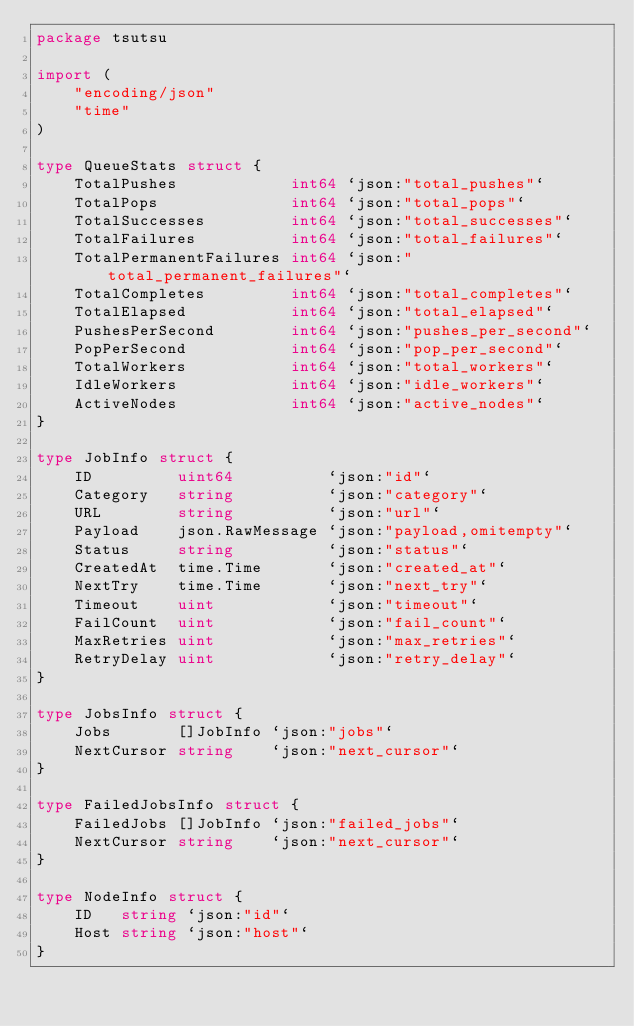Convert code to text. <code><loc_0><loc_0><loc_500><loc_500><_Go_>package tsutsu

import (
	"encoding/json"
	"time"
)

type QueueStats struct {
	TotalPushes            int64 `json:"total_pushes"`
	TotalPops              int64 `json:"total_pops"`
	TotalSuccesses         int64 `json:"total_successes"`
	TotalFailures          int64 `json:"total_failures"`
	TotalPermanentFailures int64 `json:"total_permanent_failures"`
	TotalCompletes         int64 `json:"total_completes"`
	TotalElapsed           int64 `json:"total_elapsed"`
	PushesPerSecond        int64 `json:"pushes_per_second"`
	PopPerSecond           int64 `json:"pop_per_second"`
	TotalWorkers           int64 `json:"total_workers"`
	IdleWorkers            int64 `json:"idle_workers"`
	ActiveNodes            int64 `json:"active_nodes"`
}

type JobInfo struct {
	ID         uint64          `json:"id"`
	Category   string          `json:"category"`
	URL        string          `json:"url"`
	Payload    json.RawMessage `json:"payload,omitempty"`
	Status     string          `json:"status"`
	CreatedAt  time.Time       `json:"created_at"`
	NextTry    time.Time       `json:"next_try"`
	Timeout    uint            `json:"timeout"`
	FailCount  uint            `json:"fail_count"`
	MaxRetries uint            `json:"max_retries"`
	RetryDelay uint            `json:"retry_delay"`
}

type JobsInfo struct {
	Jobs       []JobInfo `json:"jobs"`
	NextCursor string    `json:"next_cursor"`
}

type FailedJobsInfo struct {
	FailedJobs []JobInfo `json:"failed_jobs"`
	NextCursor string    `json:"next_cursor"`
}

type NodeInfo struct {
	ID   string `json:"id"`
	Host string `json:"host"`
}
</code> 